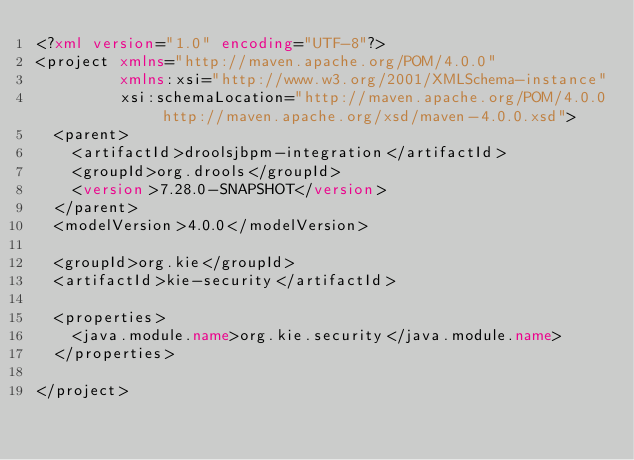<code> <loc_0><loc_0><loc_500><loc_500><_XML_><?xml version="1.0" encoding="UTF-8"?>
<project xmlns="http://maven.apache.org/POM/4.0.0"
         xmlns:xsi="http://www.w3.org/2001/XMLSchema-instance"
         xsi:schemaLocation="http://maven.apache.org/POM/4.0.0 http://maven.apache.org/xsd/maven-4.0.0.xsd">
  <parent>
    <artifactId>droolsjbpm-integration</artifactId>
    <groupId>org.drools</groupId>
    <version>7.28.0-SNAPSHOT</version>
  </parent>
  <modelVersion>4.0.0</modelVersion>

  <groupId>org.kie</groupId>
  <artifactId>kie-security</artifactId>

  <properties>
    <java.module.name>org.kie.security</java.module.name>
  </properties>

</project></code> 